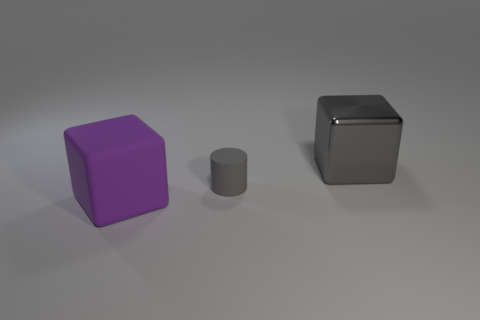Add 2 small gray things. How many objects exist? 5 Subtract all cubes. How many objects are left? 1 Subtract all red spheres. How many yellow blocks are left? 0 Subtract all gray matte things. Subtract all small gray cubes. How many objects are left? 2 Add 1 purple rubber blocks. How many purple rubber blocks are left? 2 Add 1 big metal things. How many big metal things exist? 2 Subtract 0 cyan spheres. How many objects are left? 3 Subtract all brown blocks. Subtract all brown cylinders. How many blocks are left? 2 